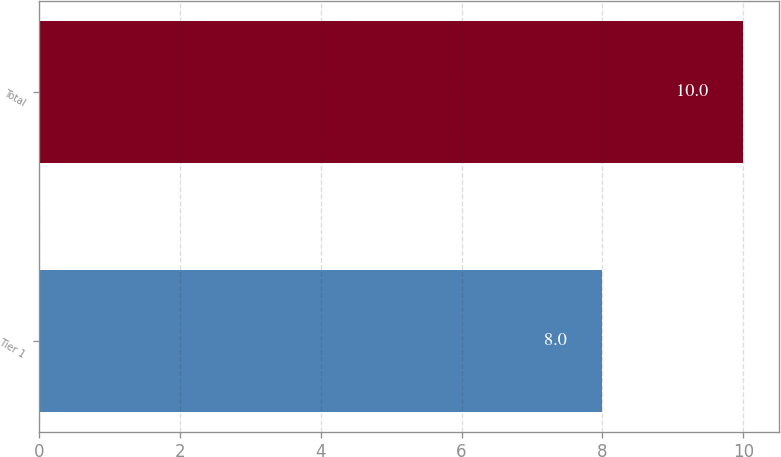Convert chart. <chart><loc_0><loc_0><loc_500><loc_500><bar_chart><fcel>Tier 1<fcel>Total<nl><fcel>8<fcel>10<nl></chart> 